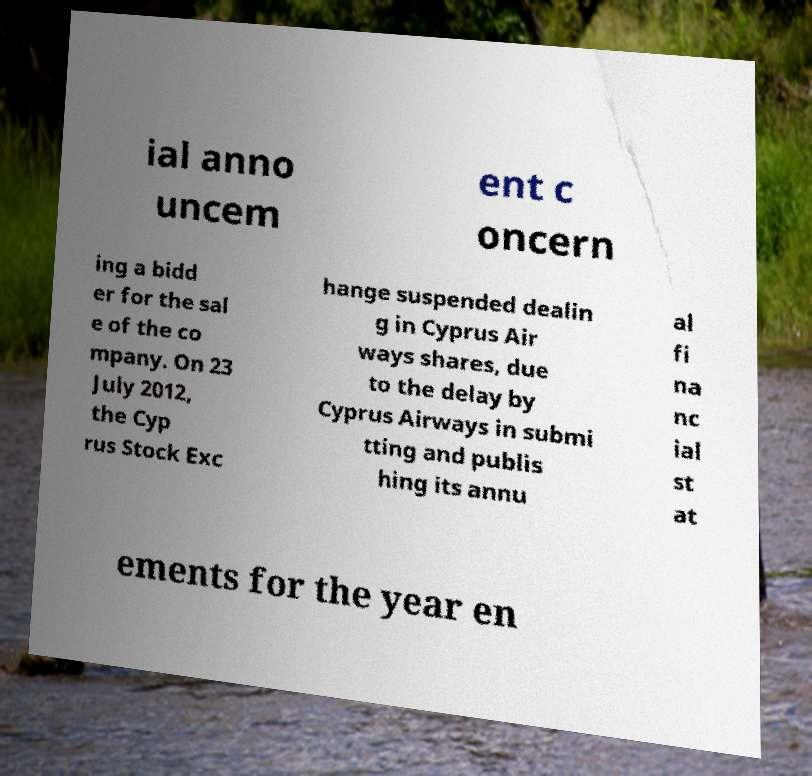Could you assist in decoding the text presented in this image and type it out clearly? ial anno uncem ent c oncern ing a bidd er for the sal e of the co mpany. On 23 July 2012, the Cyp rus Stock Exc hange suspended dealin g in Cyprus Air ways shares, due to the delay by Cyprus Airways in submi tting and publis hing its annu al fi na nc ial st at ements for the year en 